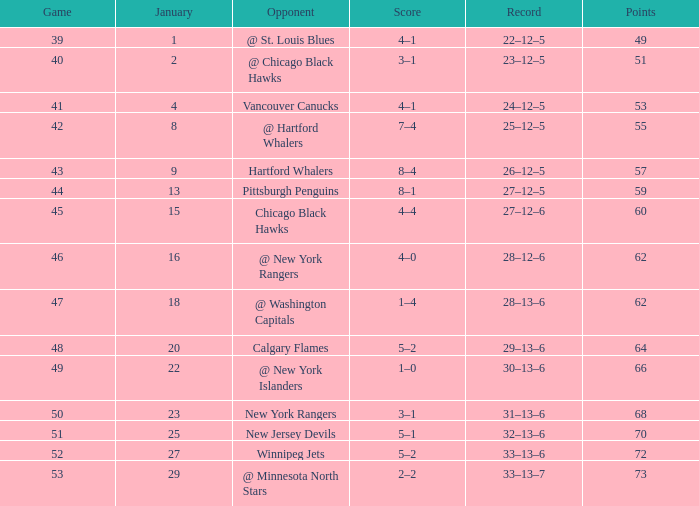Which January has a Score of 7–4, and a Game smaller than 42? None. 